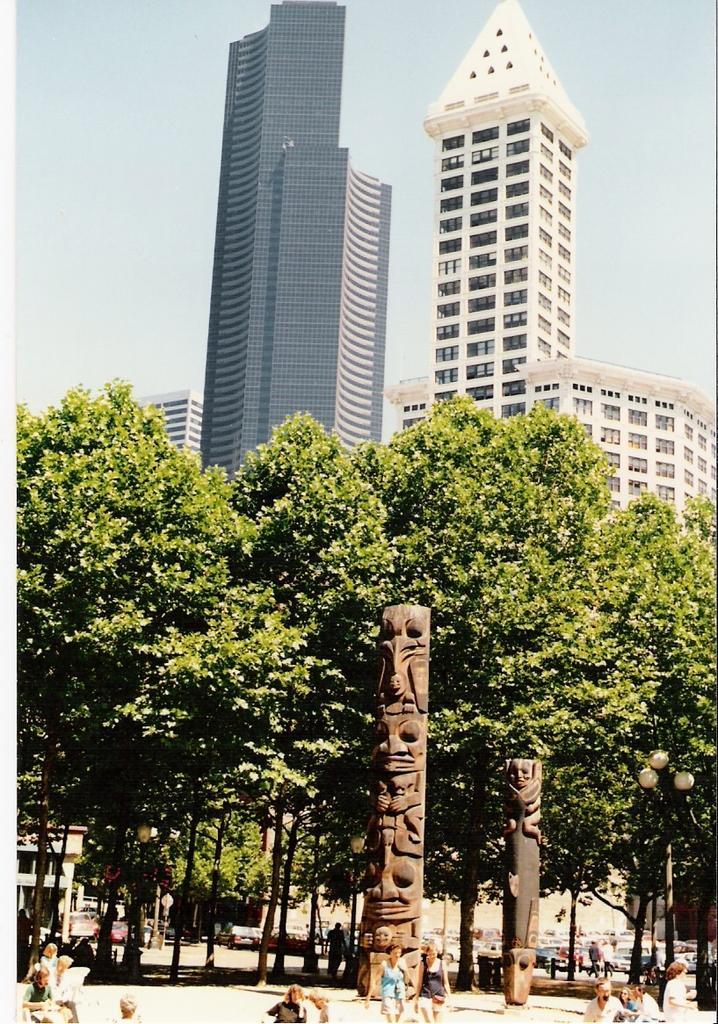Could you give a brief overview of what you see in this image? In this image we can see pillars with sculptures. There are many people. In the back there are trees. In the background there are buildings. And there is sky. 